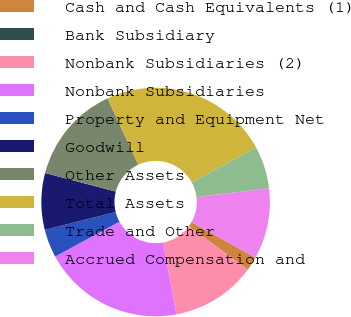<chart> <loc_0><loc_0><loc_500><loc_500><pie_chart><fcel>Cash and Cash Equivalents (1)<fcel>Bank Subsidiary<fcel>Nonbank Subsidiaries (2)<fcel>Nonbank Subsidiaries<fcel>Property and Equipment Net<fcel>Goodwill<fcel>Other Assets<fcel>Total Assets<fcel>Trade and Other<fcel>Accrued Compensation and<nl><fcel>2.0%<fcel>0.0%<fcel>12.0%<fcel>20.0%<fcel>4.0%<fcel>8.0%<fcel>14.0%<fcel>24.0%<fcel>6.0%<fcel>10.0%<nl></chart> 